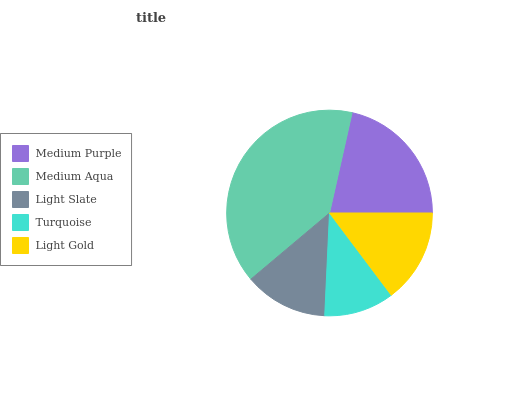Is Turquoise the minimum?
Answer yes or no. Yes. Is Medium Aqua the maximum?
Answer yes or no. Yes. Is Light Slate the minimum?
Answer yes or no. No. Is Light Slate the maximum?
Answer yes or no. No. Is Medium Aqua greater than Light Slate?
Answer yes or no. Yes. Is Light Slate less than Medium Aqua?
Answer yes or no. Yes. Is Light Slate greater than Medium Aqua?
Answer yes or no. No. Is Medium Aqua less than Light Slate?
Answer yes or no. No. Is Light Gold the high median?
Answer yes or no. Yes. Is Light Gold the low median?
Answer yes or no. Yes. Is Medium Aqua the high median?
Answer yes or no. No. Is Medium Purple the low median?
Answer yes or no. No. 